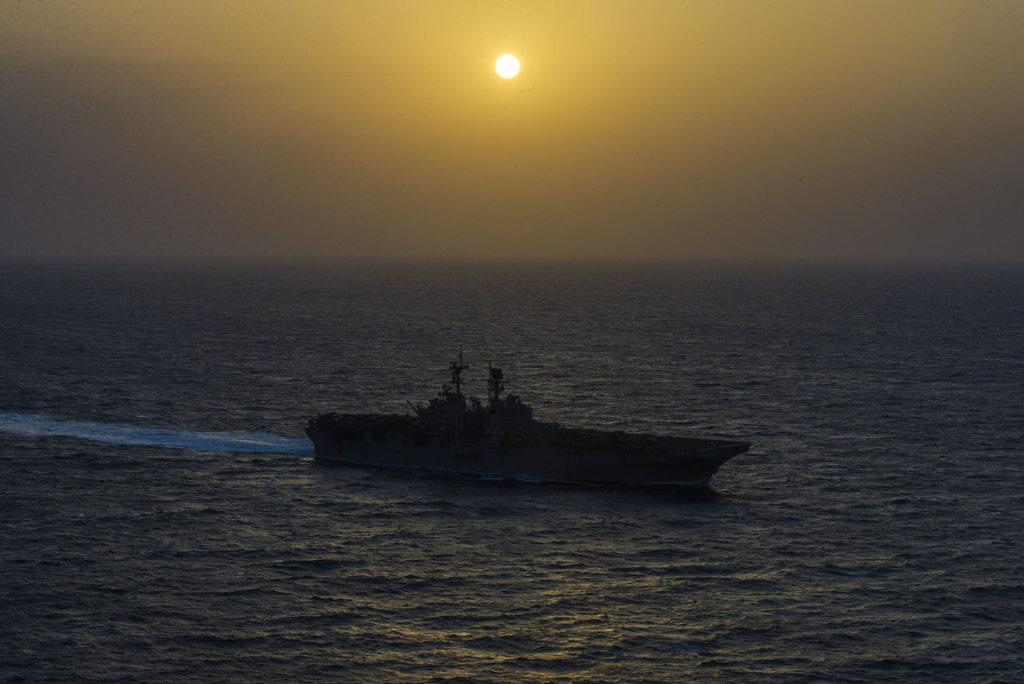What is the main subject of the image? The main subject of the image is a ship. Where is the ship located? The ship is on the water. What can be seen in the background of the image? The sun and the sky are visible in the background of the image. What type of arch can be seen in the image? There is no arch present in the image; it features a ship on the water with the sun and sky visible in the background. 